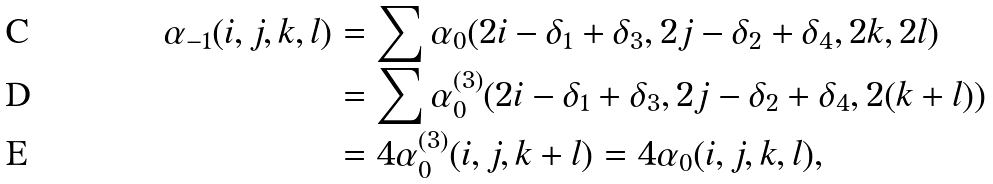Convert formula to latex. <formula><loc_0><loc_0><loc_500><loc_500>\alpha _ { - 1 } ( i , j , k , l ) & = \sum \alpha _ { 0 } ( 2 i - \delta _ { 1 } + \delta _ { 3 } , 2 j - \delta _ { 2 } + \delta _ { 4 } , 2 k , 2 l ) \\ & = \sum \alpha _ { 0 } ^ { ( 3 ) } ( 2 i - \delta _ { 1 } + \delta _ { 3 } , 2 j - \delta _ { 2 } + \delta _ { 4 } , 2 ( k + l ) ) \\ & = 4 \alpha _ { 0 } ^ { ( 3 ) } ( i , j , k + l ) = 4 \alpha _ { 0 } ( i , j , k , l ) ,</formula> 